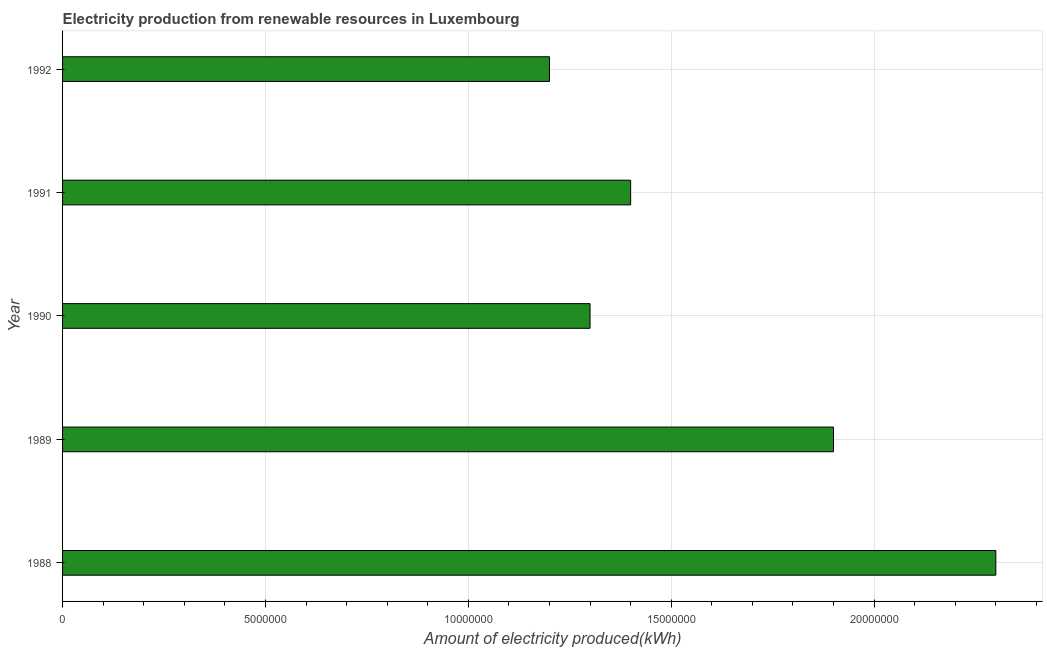Does the graph contain any zero values?
Provide a succinct answer. No. Does the graph contain grids?
Your answer should be compact. Yes. What is the title of the graph?
Make the answer very short. Electricity production from renewable resources in Luxembourg. What is the label or title of the X-axis?
Give a very brief answer. Amount of electricity produced(kWh). What is the label or title of the Y-axis?
Ensure brevity in your answer.  Year. What is the amount of electricity produced in 1989?
Offer a very short reply. 1.90e+07. Across all years, what is the maximum amount of electricity produced?
Provide a short and direct response. 2.30e+07. Across all years, what is the minimum amount of electricity produced?
Offer a terse response. 1.20e+07. In which year was the amount of electricity produced maximum?
Your response must be concise. 1988. In which year was the amount of electricity produced minimum?
Make the answer very short. 1992. What is the sum of the amount of electricity produced?
Your response must be concise. 8.10e+07. What is the difference between the amount of electricity produced in 1988 and 1990?
Ensure brevity in your answer.  1.00e+07. What is the average amount of electricity produced per year?
Offer a very short reply. 1.62e+07. What is the median amount of electricity produced?
Your response must be concise. 1.40e+07. Do a majority of the years between 1991 and 1988 (inclusive) have amount of electricity produced greater than 4000000 kWh?
Ensure brevity in your answer.  Yes. What is the ratio of the amount of electricity produced in 1988 to that in 1989?
Your answer should be very brief. 1.21. Is the difference between the amount of electricity produced in 1989 and 1990 greater than the difference between any two years?
Provide a short and direct response. No. What is the difference between the highest and the second highest amount of electricity produced?
Keep it short and to the point. 4.00e+06. Is the sum of the amount of electricity produced in 1990 and 1991 greater than the maximum amount of electricity produced across all years?
Make the answer very short. Yes. What is the difference between the highest and the lowest amount of electricity produced?
Ensure brevity in your answer.  1.10e+07. How many bars are there?
Provide a short and direct response. 5. What is the difference between two consecutive major ticks on the X-axis?
Offer a terse response. 5.00e+06. What is the Amount of electricity produced(kWh) of 1988?
Offer a very short reply. 2.30e+07. What is the Amount of electricity produced(kWh) in 1989?
Offer a terse response. 1.90e+07. What is the Amount of electricity produced(kWh) of 1990?
Provide a short and direct response. 1.30e+07. What is the Amount of electricity produced(kWh) in 1991?
Offer a terse response. 1.40e+07. What is the Amount of electricity produced(kWh) of 1992?
Provide a succinct answer. 1.20e+07. What is the difference between the Amount of electricity produced(kWh) in 1988 and 1989?
Your response must be concise. 4.00e+06. What is the difference between the Amount of electricity produced(kWh) in 1988 and 1990?
Give a very brief answer. 1.00e+07. What is the difference between the Amount of electricity produced(kWh) in 1988 and 1991?
Offer a very short reply. 9.00e+06. What is the difference between the Amount of electricity produced(kWh) in 1988 and 1992?
Make the answer very short. 1.10e+07. What is the difference between the Amount of electricity produced(kWh) in 1989 and 1990?
Offer a very short reply. 6.00e+06. What is the difference between the Amount of electricity produced(kWh) in 1989 and 1991?
Your response must be concise. 5.00e+06. What is the difference between the Amount of electricity produced(kWh) in 1989 and 1992?
Keep it short and to the point. 7.00e+06. What is the difference between the Amount of electricity produced(kWh) in 1990 and 1992?
Provide a short and direct response. 1.00e+06. What is the ratio of the Amount of electricity produced(kWh) in 1988 to that in 1989?
Keep it short and to the point. 1.21. What is the ratio of the Amount of electricity produced(kWh) in 1988 to that in 1990?
Your answer should be very brief. 1.77. What is the ratio of the Amount of electricity produced(kWh) in 1988 to that in 1991?
Provide a short and direct response. 1.64. What is the ratio of the Amount of electricity produced(kWh) in 1988 to that in 1992?
Your response must be concise. 1.92. What is the ratio of the Amount of electricity produced(kWh) in 1989 to that in 1990?
Your answer should be very brief. 1.46. What is the ratio of the Amount of electricity produced(kWh) in 1989 to that in 1991?
Make the answer very short. 1.36. What is the ratio of the Amount of electricity produced(kWh) in 1989 to that in 1992?
Give a very brief answer. 1.58. What is the ratio of the Amount of electricity produced(kWh) in 1990 to that in 1991?
Provide a succinct answer. 0.93. What is the ratio of the Amount of electricity produced(kWh) in 1990 to that in 1992?
Your response must be concise. 1.08. What is the ratio of the Amount of electricity produced(kWh) in 1991 to that in 1992?
Your answer should be very brief. 1.17. 